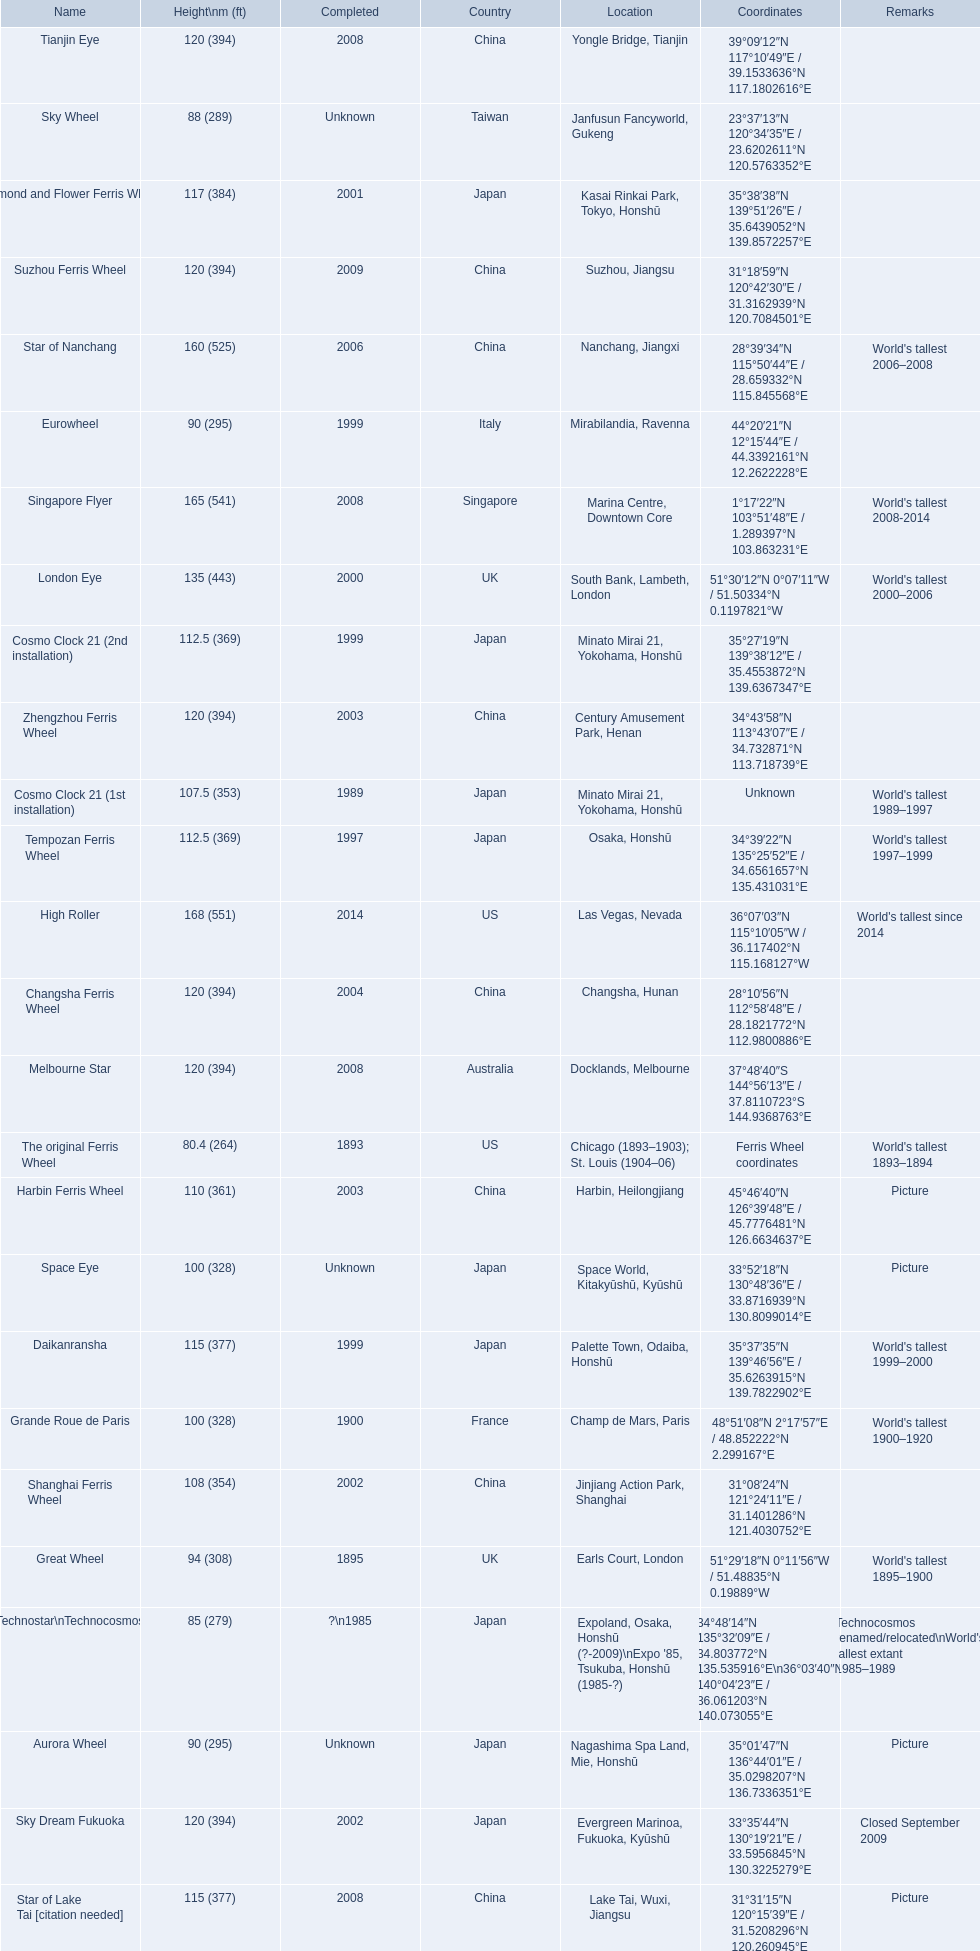How tall is the roller coaster star of nanchang? 165 (541). When was the roller coaster star of nanchang completed? 2008. What is the name of the oldest roller coaster? Star of Nanchang. 